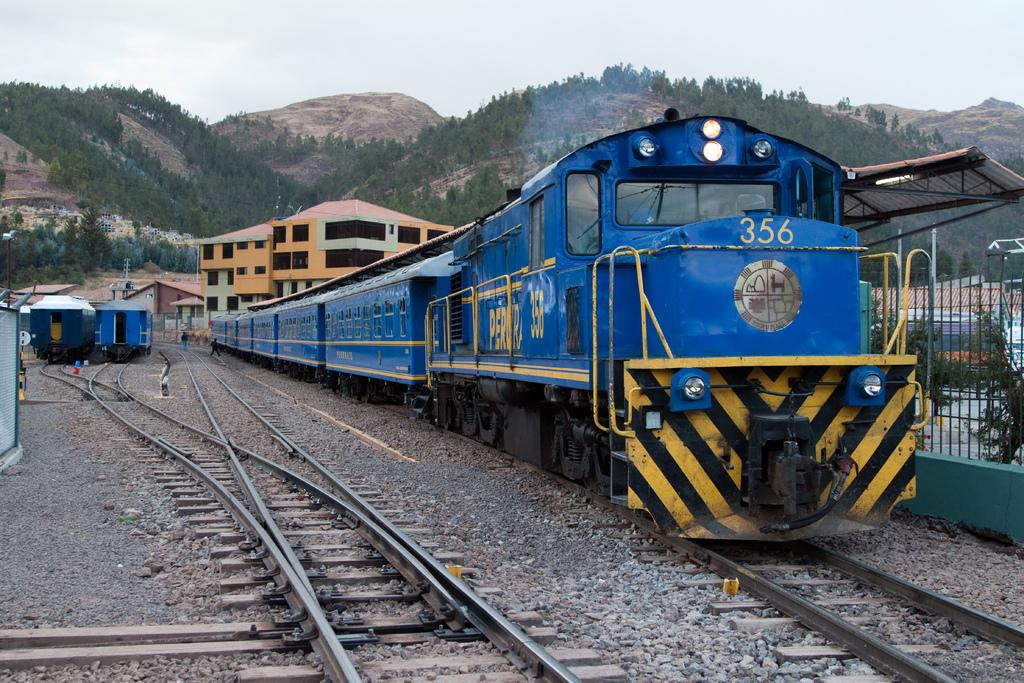<image>
Write a terse but informative summary of the picture. a blue train sits on a track has the number 356 on the nose 